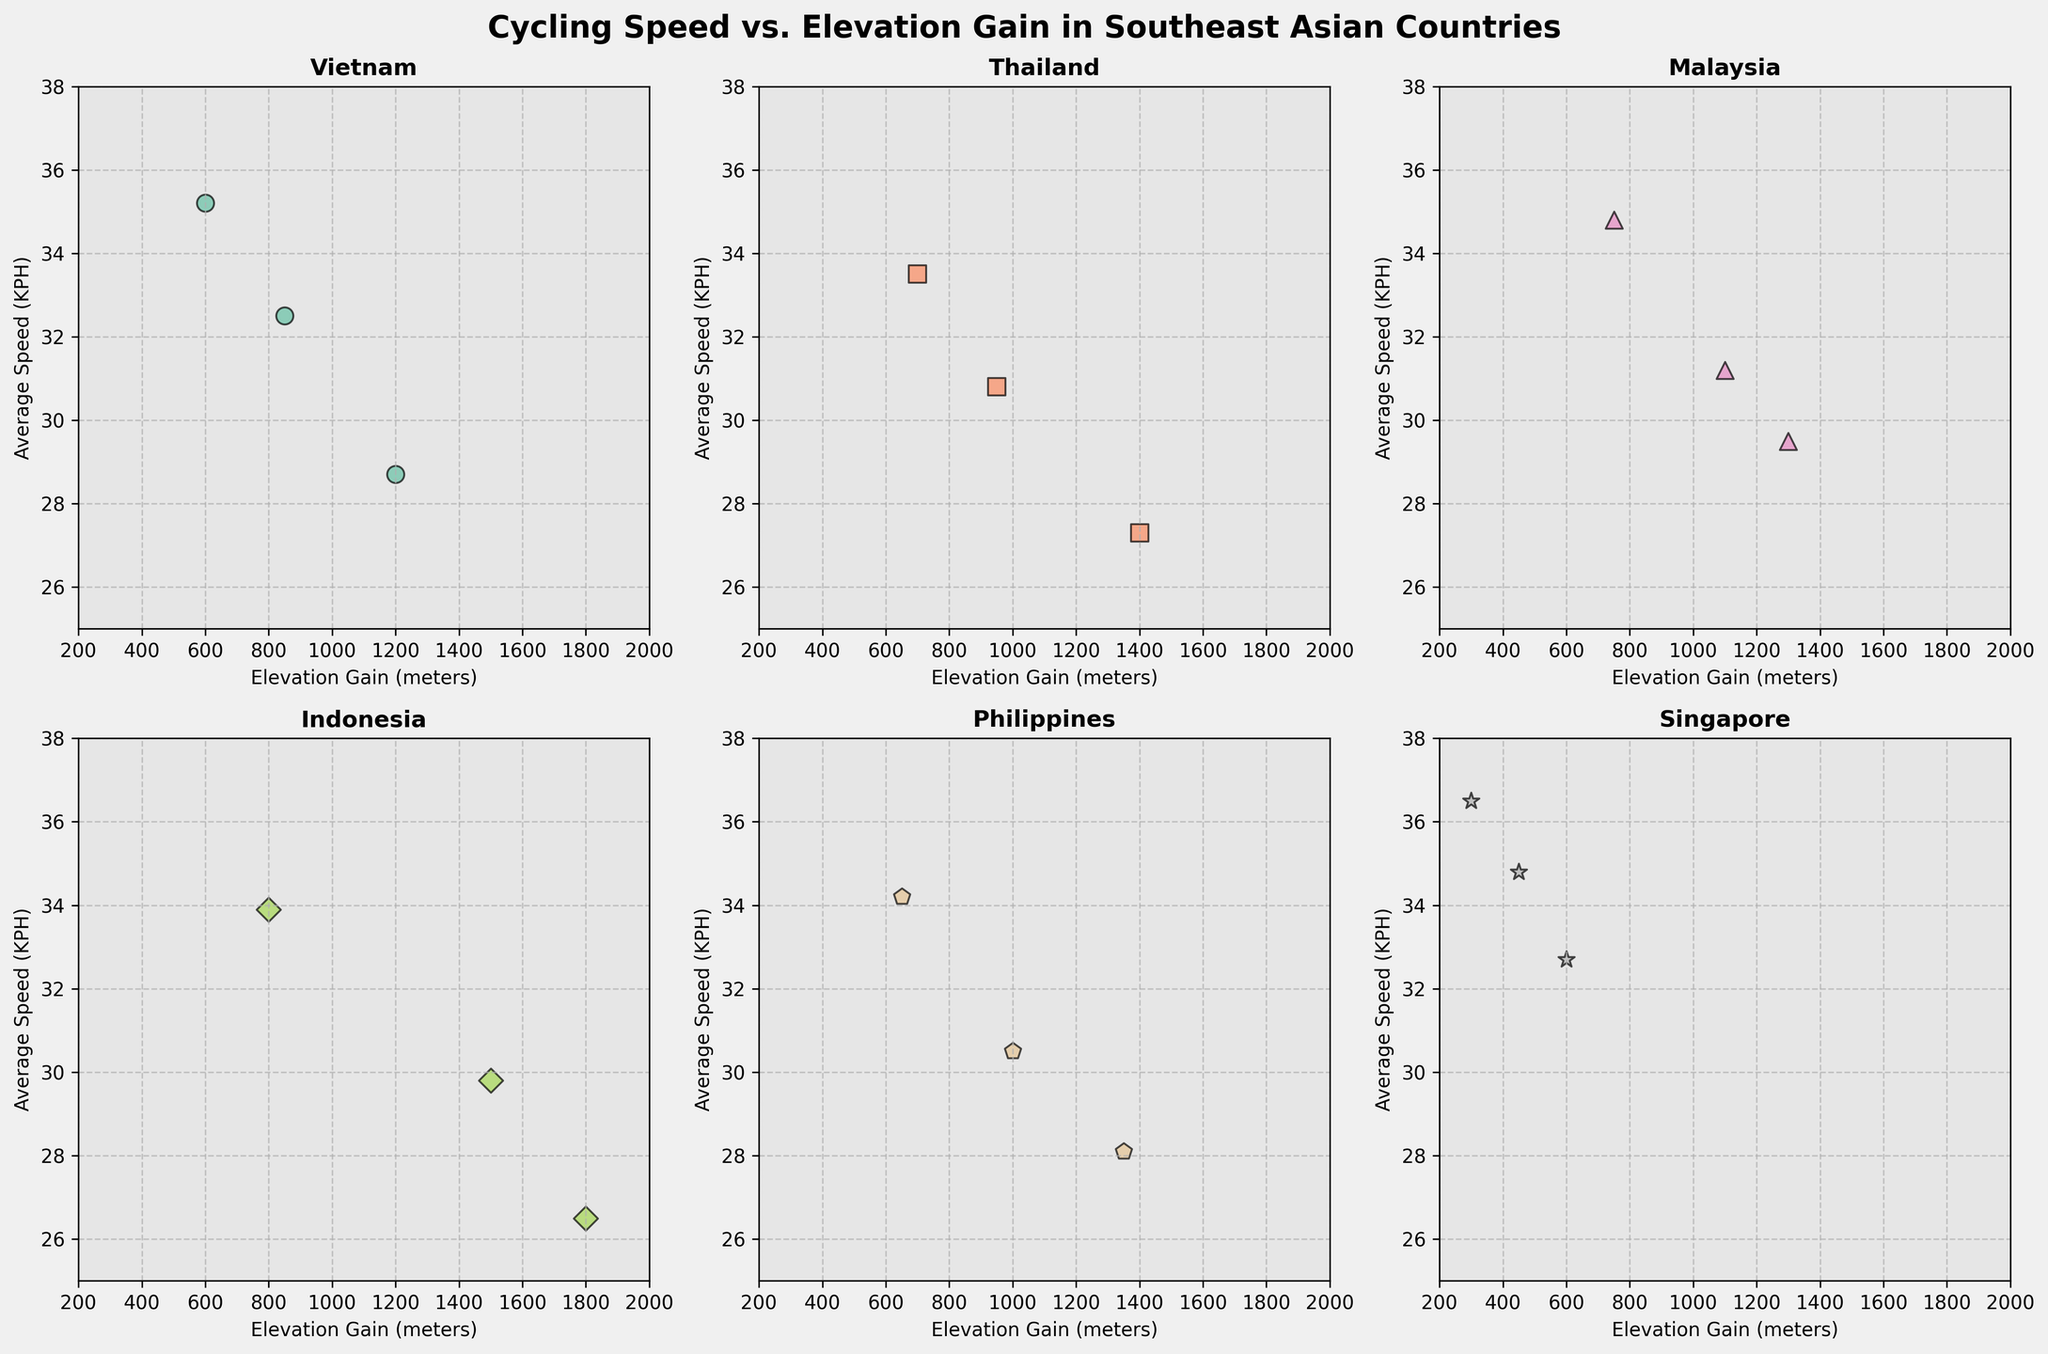Which country has the highest recorded average speed? From the charts, Singapore features the highest average speed data point of 36.5 KPH.
Answer: Singapore How many data points are plotted for Indonesia? Each subplot represents a Southeast Asian country, and counting the individual points in Indonesia's plot reveals there are 3 data points.
Answer: 3 What is the typical average speed range for Vietnam? The scatter plot for Vietnam shows data points with average speeds ranging from around 28 to 35.2 KPH.
Answer: 28-35.2 KPH Which country tends to have the highest elevation gains during cycling? The plot for Indonesia showcases the highest elevation gains, with data points reaching up to 1800 meters.
Answer: Indonesia Does Malaysia generally have higher average speeds or higher elevation gains compared to Thailand? By observing the plots, Malaysia generally shows higher average speeds (up to 34.8 KPH) while elevation gains go up to 1300 meters, compared to Thailand's maximum speed of 33.5 KPH and elevation gain of 1400 meters.
Answer: Higher average speeds How do the average speeds in Singapore compare to those in the Philippines? Singapore's average speeds range from 32.7 to 36.5 KPH, while the Philippines shows speeds from 28.1 to 34.2 KPH, indicating Singapore has generally higher average speeds.
Answer: Higher in Singapore Which country's cyclists experience the least variation in elevation gain? Singapore's subplot shows the narrowest range of elevation gains, from 300 to 600 meters, compared to the larger spreads in other countries.
Answer: Singapore Are there any countries where average speed decreases as elevation gain increases? From the scatter plots, Indonesia shows a trend where the average speed appears to decrease as the elevation gain increases.
Answer: Yes, Indonesia What's the maximum elevation gain recorded in the Philippines? The plot for the Philippines displays a maximum elevation gain of 1350 meters.
Answer: 1350 meters Compare the range of average speeds for Thailand and Malaysia. Thailand's average speeds range between 27.3 KPH and 33.5 KPH, whereas Malaysia's speeds range between 29.5 KPH and 34.8 KPH, indicating Malaysia has a slightly higher range of average speeds.
Answer: Malaysia has a higher range 